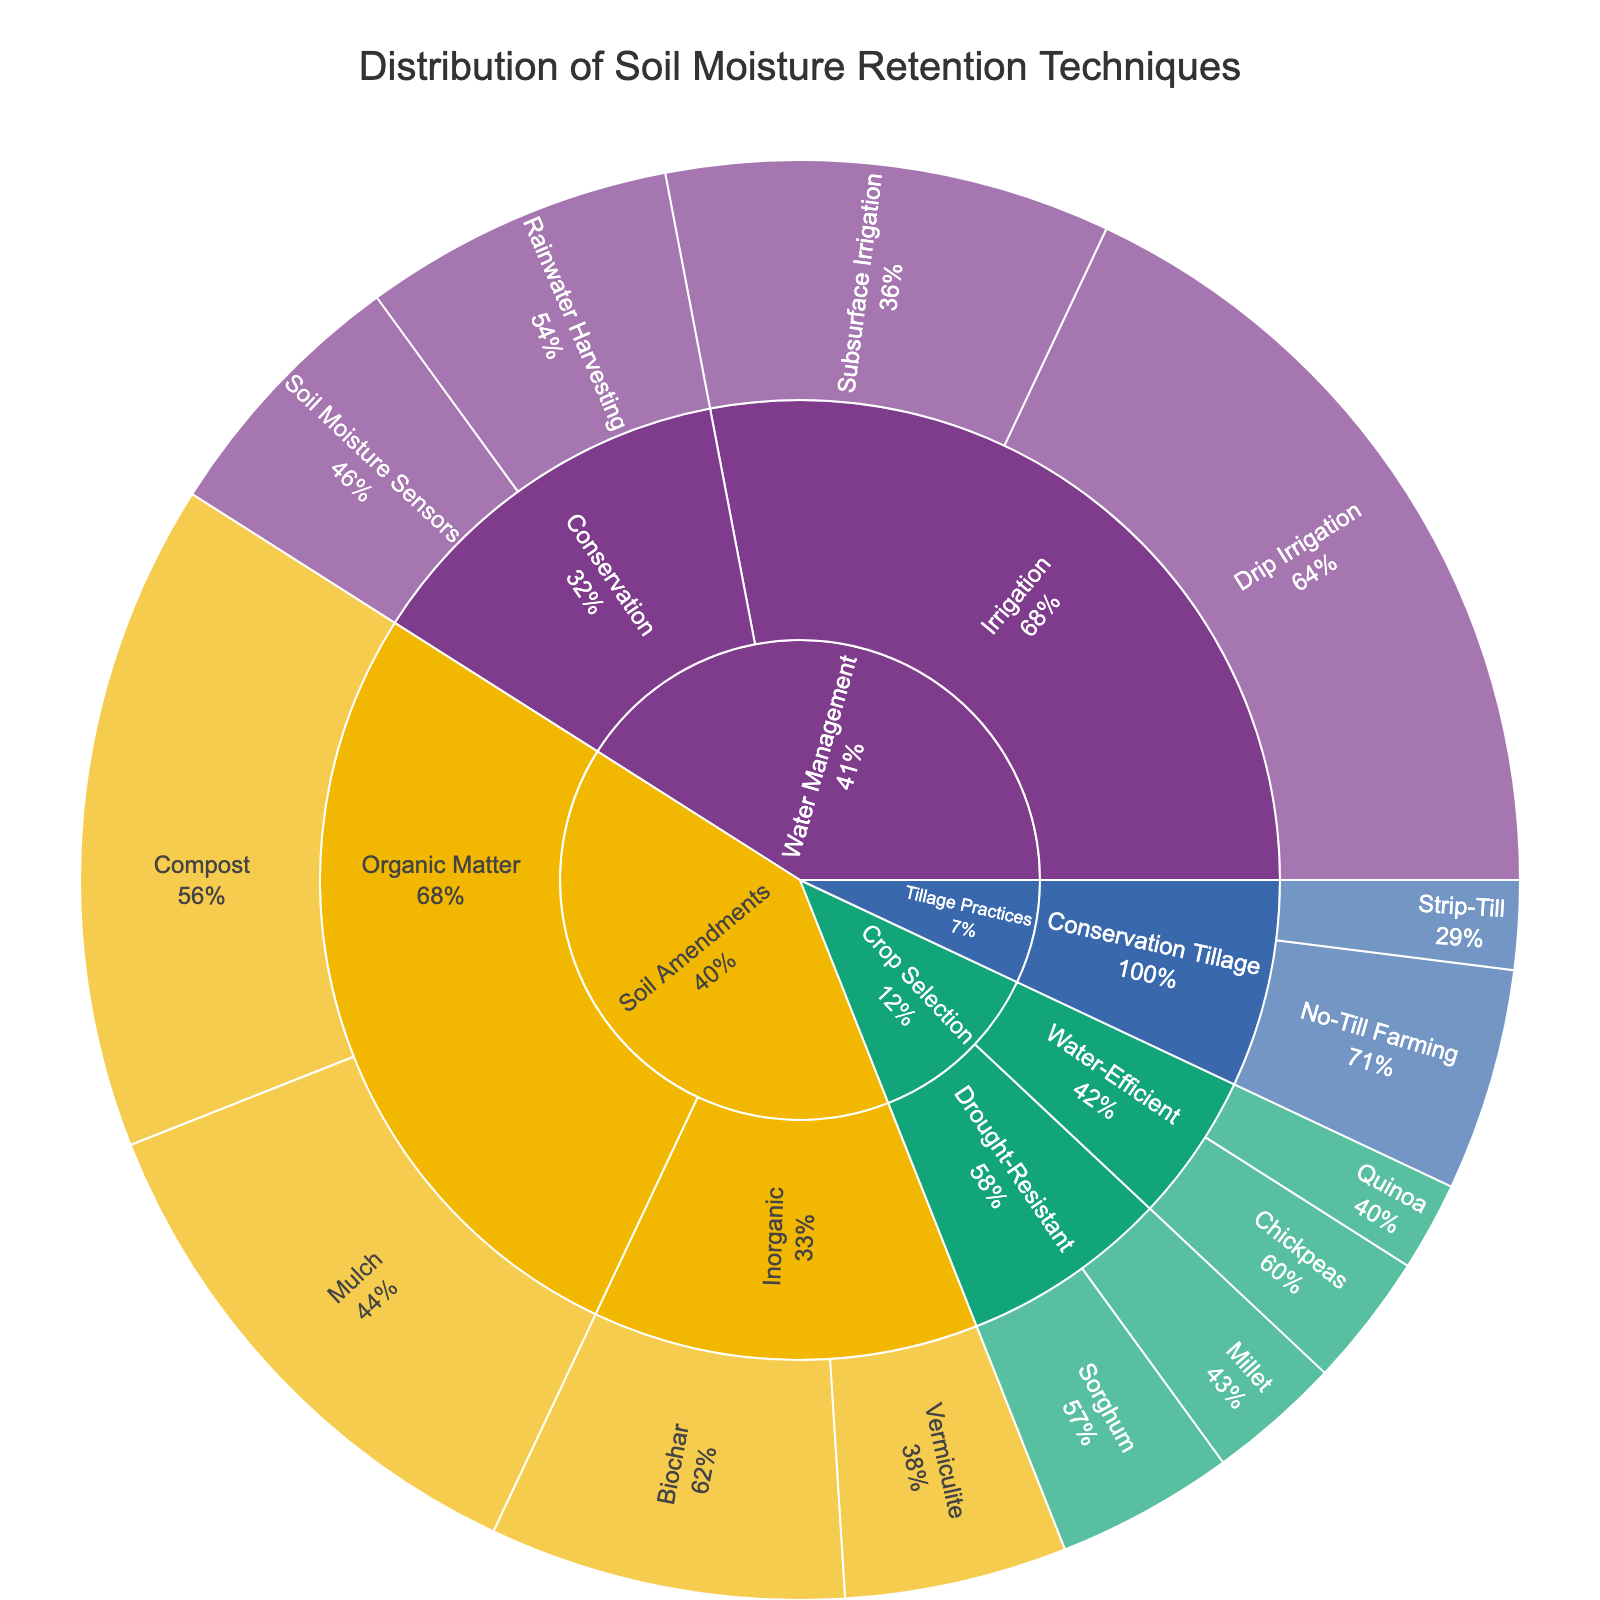What is the title of the sunburst plot? The title text is often displayed prominently at the top of the plot. By reading the text directly, one can determine the title.
Answer: Distribution of Soil Moisture Retention Techniques Which category has the highest percentage for a single technique? To determine this, we need to identify the category and technique with the largest percentage value on the plot.
Answer: Water Management with Drip Irrigation (18%) How much percentage is dedicated to Organic Matter in the Soil Amendments category? Sum up the percentages of 'Compost' and 'Mulch' under the 'Organic Matter' subcategory in the 'Soil Amendments' category: 15% + 12% = 27%.
Answer: 27% What are the subcategories under Crop Selection? Look at the branches extending from the 'Crop Selection' category to identify the subcategories.
Answer: Drought-Resistant, Water-Efficient Which technique under the Water Management category has a higher percentage, Rainwater Harvesting or Soil Moisture Sensors? Look at the two techniques under the 'Conservation' subcategory of 'Water Management' and compare their percentages.
Answer: Rainwater Harvesting (7%) is higher than Soil Moisture Sensors (6%) How does the percentage of No-Till Farming compare to Strip-Till in the Conservation Tillage subcategory? Examine the percentages of 'No-Till Farming' (5%) and 'Strip-Till' (2%) under the 'Conservation Tillage' subcategory and compare their values.
Answer: No-Till Farming has a higher percentage than Strip-Till What is the combined percentage for all techniques under Inorganic in the Soil Amendments category? Add up the percentages of 'Biochar' and 'Vermiculite' under the 'Inorganic' subcategory of 'Soil Amendments': 8% + 5% = 13%.
Answer: 13% Which category has the smallest total percentage? Sum up the percentages of techniques in each category and compare them to find the smallest total. 'Crop Selection' has a total of 4% + 3% + 2% + 3% = 12%.
Answer: Crop Selection What is the percentage difference between Drip Irrigation and Subsurface Irrigation under the Water Management category? Subtract the percentage of Subsurface Irrigation (10%) from Drip Irrigation (18%) for the difference: 18% - 10% = 8%.
Answer: 8% As a percentage of the total, how much does the Soil Amendments category represent? Sum all the percentages under the Soil Amendments category: Compost (15%) + Mulch (12%) + Biochar (8%) + Vermiculite (5%) = 40%.
Answer: 40% 